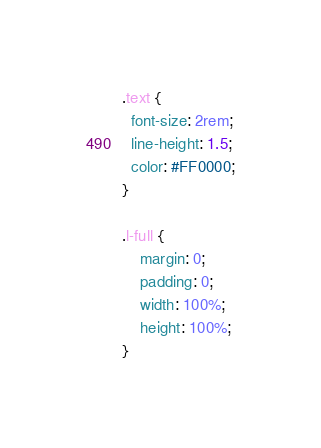Convert code to text. <code><loc_0><loc_0><loc_500><loc_500><_CSS_>.text {
  font-size: 2rem;
  line-height: 1.5;
  color: #FF0000;
}

.l-full {
    margin: 0;
    padding: 0;
    width: 100%;
    height: 100%;
}
</code> 